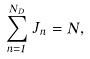Convert formula to latex. <formula><loc_0><loc_0><loc_500><loc_500>\sum _ { n = 1 } ^ { N _ { D } } \, J _ { n } = N ,</formula> 